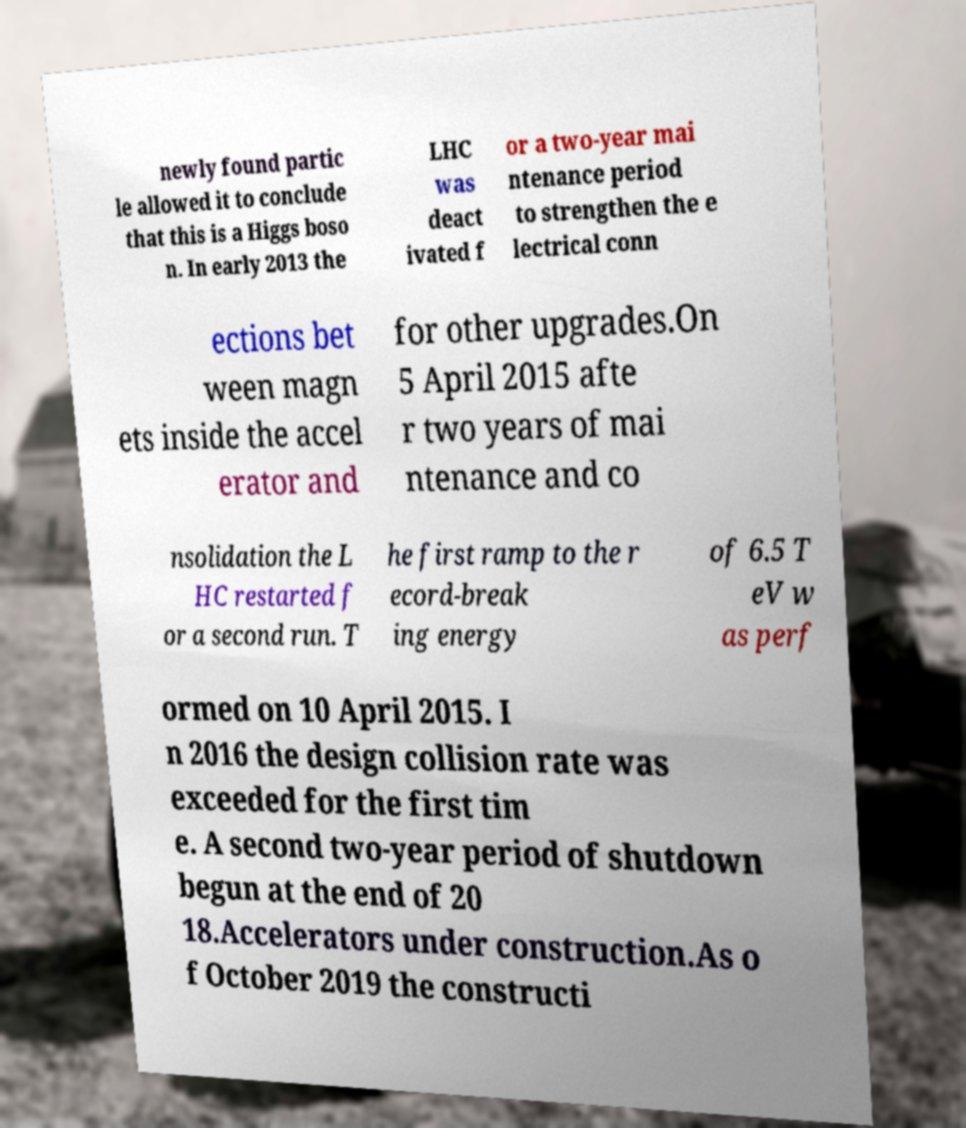Please identify and transcribe the text found in this image. newly found partic le allowed it to conclude that this is a Higgs boso n. In early 2013 the LHC was deact ivated f or a two-year mai ntenance period to strengthen the e lectrical conn ections bet ween magn ets inside the accel erator and for other upgrades.On 5 April 2015 afte r two years of mai ntenance and co nsolidation the L HC restarted f or a second run. T he first ramp to the r ecord-break ing energy of 6.5 T eV w as perf ormed on 10 April 2015. I n 2016 the design collision rate was exceeded for the first tim e. A second two-year period of shutdown begun at the end of 20 18.Accelerators under construction.As o f October 2019 the constructi 